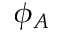Convert formula to latex. <formula><loc_0><loc_0><loc_500><loc_500>\phi _ { A }</formula> 